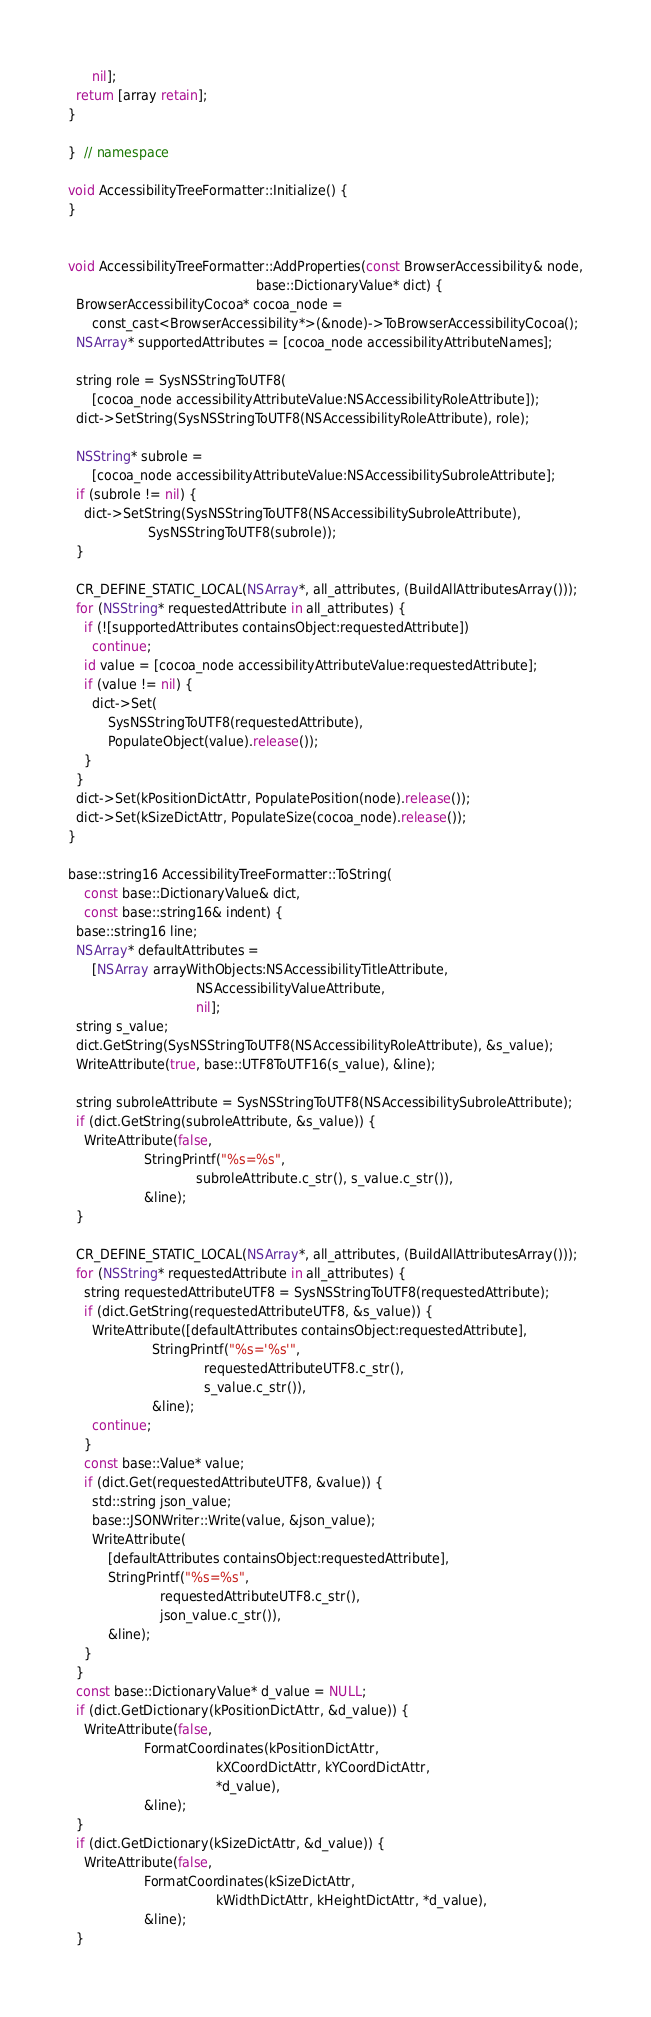<code> <loc_0><loc_0><loc_500><loc_500><_ObjectiveC_>      nil];
  return [array retain];
}

}  // namespace

void AccessibilityTreeFormatter::Initialize() {
}


void AccessibilityTreeFormatter::AddProperties(const BrowserAccessibility& node,
                                               base::DictionaryValue* dict) {
  BrowserAccessibilityCocoa* cocoa_node =
      const_cast<BrowserAccessibility*>(&node)->ToBrowserAccessibilityCocoa();
  NSArray* supportedAttributes = [cocoa_node accessibilityAttributeNames];

  string role = SysNSStringToUTF8(
      [cocoa_node accessibilityAttributeValue:NSAccessibilityRoleAttribute]);
  dict->SetString(SysNSStringToUTF8(NSAccessibilityRoleAttribute), role);

  NSString* subrole =
      [cocoa_node accessibilityAttributeValue:NSAccessibilitySubroleAttribute];
  if (subrole != nil) {
    dict->SetString(SysNSStringToUTF8(NSAccessibilitySubroleAttribute),
                    SysNSStringToUTF8(subrole));
  }

  CR_DEFINE_STATIC_LOCAL(NSArray*, all_attributes, (BuildAllAttributesArray()));
  for (NSString* requestedAttribute in all_attributes) {
    if (![supportedAttributes containsObject:requestedAttribute])
      continue;
    id value = [cocoa_node accessibilityAttributeValue:requestedAttribute];
    if (value != nil) {
      dict->Set(
          SysNSStringToUTF8(requestedAttribute),
          PopulateObject(value).release());
    }
  }
  dict->Set(kPositionDictAttr, PopulatePosition(node).release());
  dict->Set(kSizeDictAttr, PopulateSize(cocoa_node).release());
}

base::string16 AccessibilityTreeFormatter::ToString(
    const base::DictionaryValue& dict,
    const base::string16& indent) {
  base::string16 line;
  NSArray* defaultAttributes =
      [NSArray arrayWithObjects:NSAccessibilityTitleAttribute,
                                NSAccessibilityValueAttribute,
                                nil];
  string s_value;
  dict.GetString(SysNSStringToUTF8(NSAccessibilityRoleAttribute), &s_value);
  WriteAttribute(true, base::UTF8ToUTF16(s_value), &line);

  string subroleAttribute = SysNSStringToUTF8(NSAccessibilitySubroleAttribute);
  if (dict.GetString(subroleAttribute, &s_value)) {
    WriteAttribute(false,
                   StringPrintf("%s=%s",
                                subroleAttribute.c_str(), s_value.c_str()),
                   &line);
  }

  CR_DEFINE_STATIC_LOCAL(NSArray*, all_attributes, (BuildAllAttributesArray()));
  for (NSString* requestedAttribute in all_attributes) {
    string requestedAttributeUTF8 = SysNSStringToUTF8(requestedAttribute);
    if (dict.GetString(requestedAttributeUTF8, &s_value)) {
      WriteAttribute([defaultAttributes containsObject:requestedAttribute],
                     StringPrintf("%s='%s'",
                                  requestedAttributeUTF8.c_str(),
                                  s_value.c_str()),
                     &line);
      continue;
    }
    const base::Value* value;
    if (dict.Get(requestedAttributeUTF8, &value)) {
      std::string json_value;
      base::JSONWriter::Write(value, &json_value);
      WriteAttribute(
          [defaultAttributes containsObject:requestedAttribute],
          StringPrintf("%s=%s",
                       requestedAttributeUTF8.c_str(),
                       json_value.c_str()),
          &line);
    }
  }
  const base::DictionaryValue* d_value = NULL;
  if (dict.GetDictionary(kPositionDictAttr, &d_value)) {
    WriteAttribute(false,
                   FormatCoordinates(kPositionDictAttr,
                                     kXCoordDictAttr, kYCoordDictAttr,
                                     *d_value),
                   &line);
  }
  if (dict.GetDictionary(kSizeDictAttr, &d_value)) {
    WriteAttribute(false,
                   FormatCoordinates(kSizeDictAttr,
                                     kWidthDictAttr, kHeightDictAttr, *d_value),
                   &line);
  }
</code> 